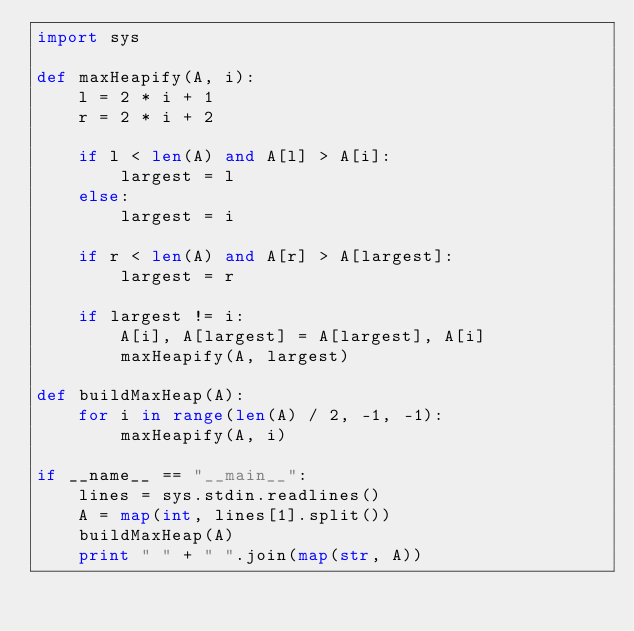Convert code to text. <code><loc_0><loc_0><loc_500><loc_500><_Python_>import sys

def maxHeapify(A, i):
    l = 2 * i + 1
    r = 2 * i + 2

    if l < len(A) and A[l] > A[i]:
        largest = l
    else:
        largest = i

    if r < len(A) and A[r] > A[largest]:
        largest = r

    if largest != i:
        A[i], A[largest] = A[largest], A[i]
        maxHeapify(A, largest)

def buildMaxHeap(A):
    for i in range(len(A) / 2, -1, -1):
        maxHeapify(A, i)

if __name__ == "__main__":
    lines = sys.stdin.readlines()
    A = map(int, lines[1].split())
    buildMaxHeap(A)
    print " " + " ".join(map(str, A))</code> 